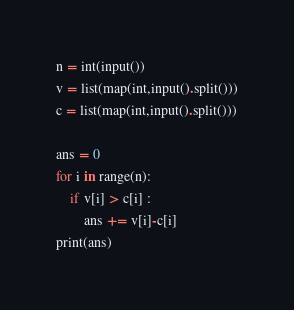<code> <loc_0><loc_0><loc_500><loc_500><_Python_>n = int(input())
v = list(map(int,input().split()))
c = list(map(int,input().split()))

ans = 0
for i in range(n):
    if v[i] > c[i] :
        ans += v[i]-c[i]
print(ans)
</code> 